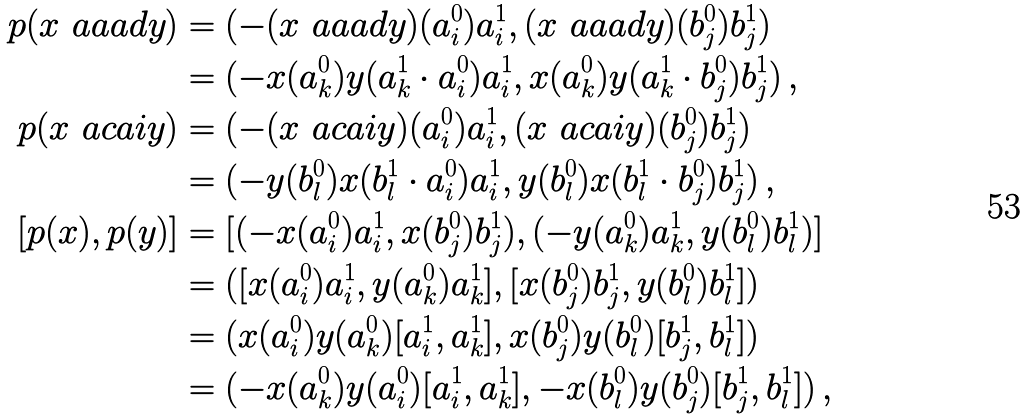<formula> <loc_0><loc_0><loc_500><loc_500>p ( x \ a a a d y ) & = ( - ( x \ a a a d y ) ( a ^ { 0 } _ { i } ) a ^ { 1 } _ { i } , ( x \ a a a d y ) ( b ^ { 0 } _ { j } ) b ^ { 1 } _ { j } ) \\ & = ( - x ( a ^ { 0 } _ { k } ) y ( a ^ { 1 } _ { k } \cdot a ^ { 0 } _ { i } ) a ^ { 1 } _ { i } , x ( a ^ { 0 } _ { k } ) y ( a ^ { 1 } _ { k } \cdot b ^ { 0 } _ { j } ) b ^ { 1 } _ { j } ) \, , \\ p ( x \ a c a i y ) & = ( - ( x \ a c a i y ) ( a ^ { 0 } _ { i } ) a ^ { 1 } _ { i } , ( x \ a c a i y ) ( b ^ { 0 } _ { j } ) b ^ { 1 } _ { j } ) \\ & = ( - y ( b ^ { 0 } _ { l } ) x ( b ^ { 1 } _ { l } \cdot a ^ { 0 } _ { i } ) a ^ { 1 } _ { i } , y ( b ^ { 0 } _ { l } ) x ( b ^ { 1 } _ { l } \cdot b ^ { 0 } _ { j } ) b ^ { 1 } _ { j } ) \, , \\ [ p ( x ) , p ( y ) ] & = [ ( - x ( a ^ { 0 } _ { i } ) a ^ { 1 } _ { i } , x ( b ^ { 0 } _ { j } ) b ^ { 1 } _ { j } ) , ( - y ( a ^ { 0 } _ { k } ) a ^ { 1 } _ { k } , y ( b ^ { 0 } _ { l } ) b ^ { 1 } _ { l } ) ] \\ & = ( [ x ( a ^ { 0 } _ { i } ) a ^ { 1 } _ { i } , y ( a ^ { 0 } _ { k } ) a ^ { 1 } _ { k } ] , [ x ( b ^ { 0 } _ { j } ) b ^ { 1 } _ { j } , y ( b ^ { 0 } _ { l } ) b ^ { 1 } _ { l } ] ) \\ & = ( x ( a ^ { 0 } _ { i } ) y ( a ^ { 0 } _ { k } ) [ a ^ { 1 } _ { i } , a ^ { 1 } _ { k } ] , x ( b ^ { 0 } _ { j } ) y ( b ^ { 0 } _ { l } ) [ b ^ { 1 } _ { j } , b ^ { 1 } _ { l } ] ) \\ & = ( - x ( a ^ { 0 } _ { k } ) y ( a ^ { 0 } _ { i } ) [ a ^ { 1 } _ { i } , a ^ { 1 } _ { k } ] , - x ( b ^ { 0 } _ { l } ) y ( b ^ { 0 } _ { j } ) [ b ^ { 1 } _ { j } , b ^ { 1 } _ { l } ] ) \, , \\</formula> 